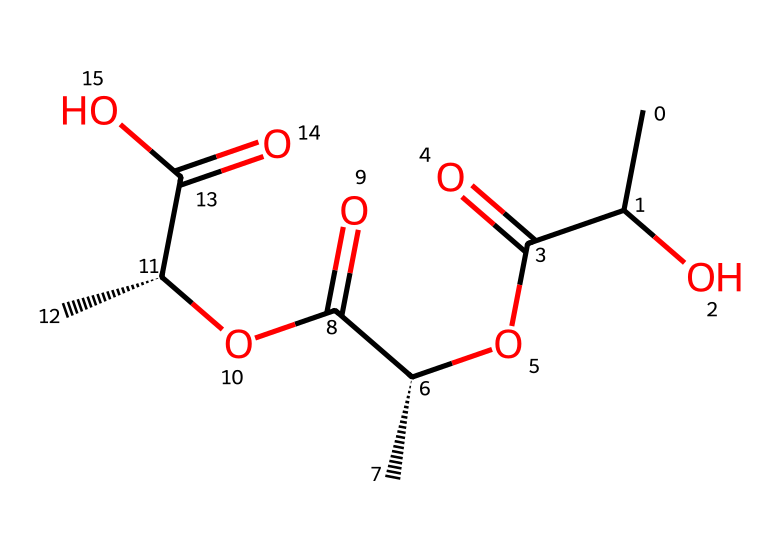What type of polymer is represented by this SMILES? The structure suggests a biopolymer due to the presence of ester and carboxylic acid functional groups, which are common in biodegradable polymers.
Answer: biopolymer How many oxygen atoms are present in this structure? By counting the oxygen atoms in the SMILES representation, there are a total of 6 oxygen atoms (the O atoms in ester and carboxylic groups).
Answer: 6 What type of linkage is primarily found in this polymer? The presence of ester groups indicates that the primary linkage in this polymer is an ester linkage, which is characteristic of many biodegradable polymers.
Answer: ester linkage What is the total number of carbon atoms in this polymer's structure? The carbon atoms can be counted from the SMILES, totaling 9 carbon atoms present in the backbone and side groups of the structure.
Answer: 9 Does this polymer have any chiral centers? Analyzing the SMILES, two carbon atoms are indicated with the '@' symbol, which denotes chirality, confirming the presence of chiral centers.
Answer: yes What is the potential advantage of using this polymer for food packaging? The key advantage inferred from the biodegradability of this polymer is its ability to decompose naturally, reducing environmental impact compared to conventional plastics.
Answer: biodegradability 